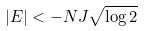Convert formula to latex. <formula><loc_0><loc_0><loc_500><loc_500>| E | < - N J \sqrt { \log 2 }</formula> 